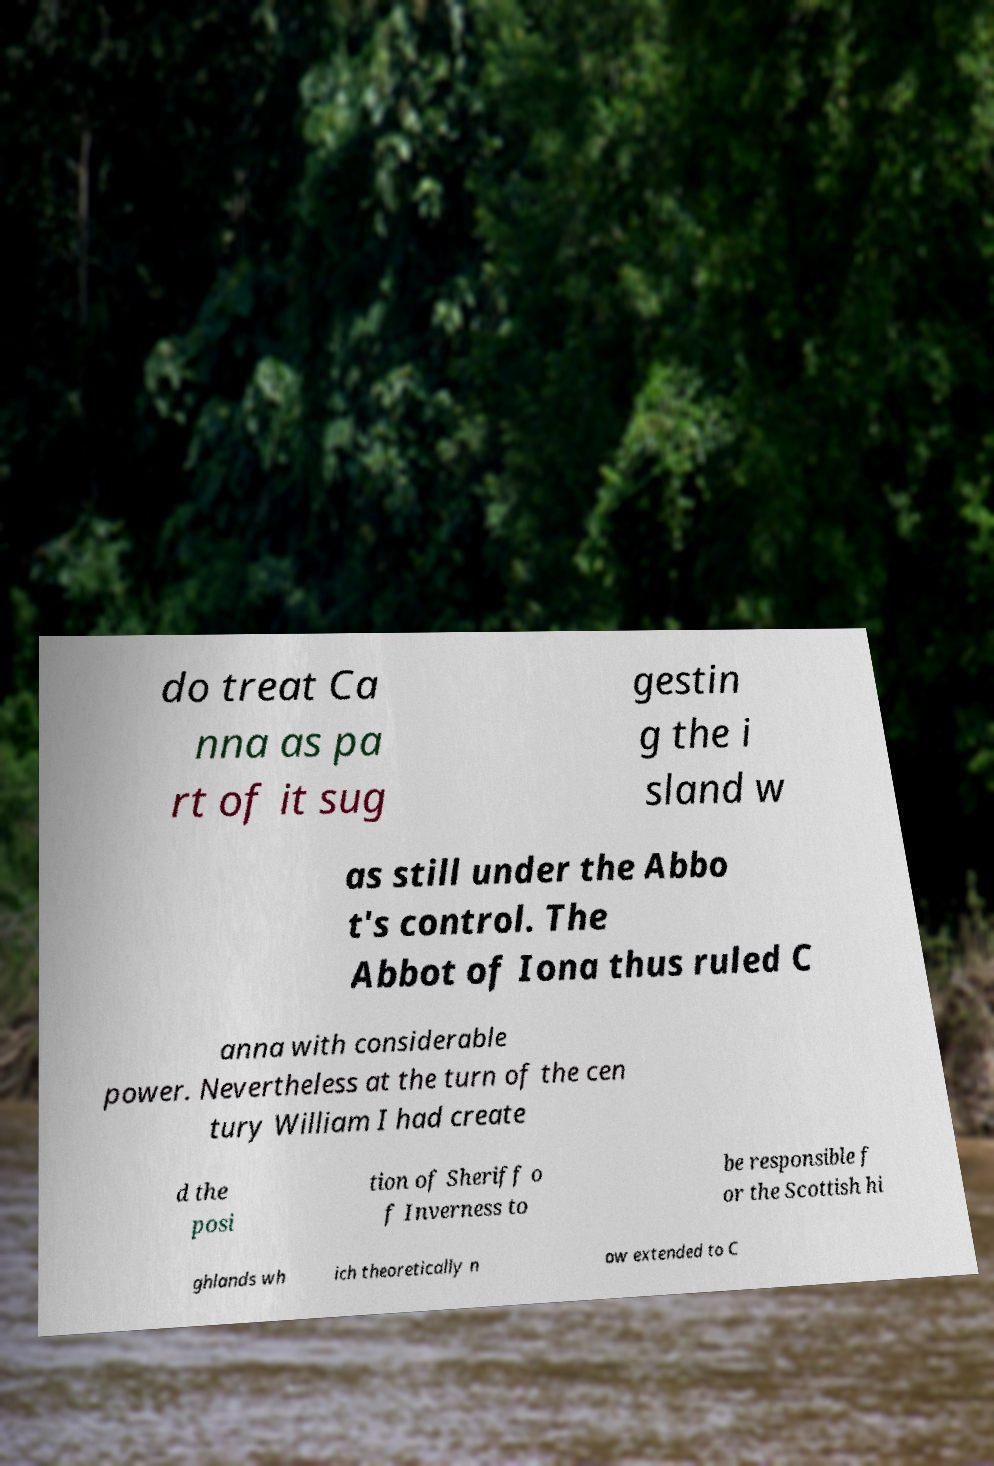Can you read and provide the text displayed in the image?This photo seems to have some interesting text. Can you extract and type it out for me? do treat Ca nna as pa rt of it sug gestin g the i sland w as still under the Abbo t's control. The Abbot of Iona thus ruled C anna with considerable power. Nevertheless at the turn of the cen tury William I had create d the posi tion of Sheriff o f Inverness to be responsible f or the Scottish hi ghlands wh ich theoretically n ow extended to C 